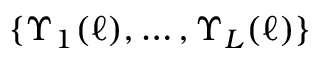<formula> <loc_0><loc_0><loc_500><loc_500>\{ \Upsilon _ { 1 } ( \ell ) , \dots , \Upsilon _ { L } ( \ell ) \}</formula> 